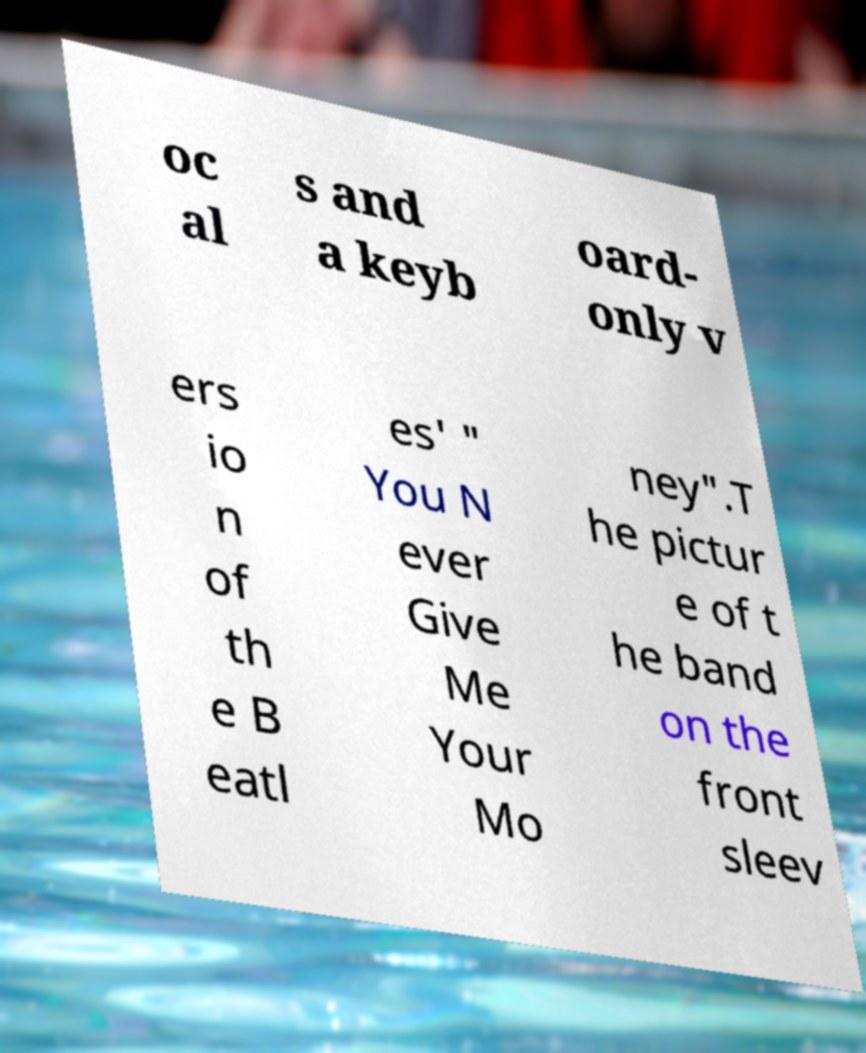There's text embedded in this image that I need extracted. Can you transcribe it verbatim? oc al s and a keyb oard- only v ers io n of th e B eatl es' " You N ever Give Me Your Mo ney".T he pictur e of t he band on the front sleev 